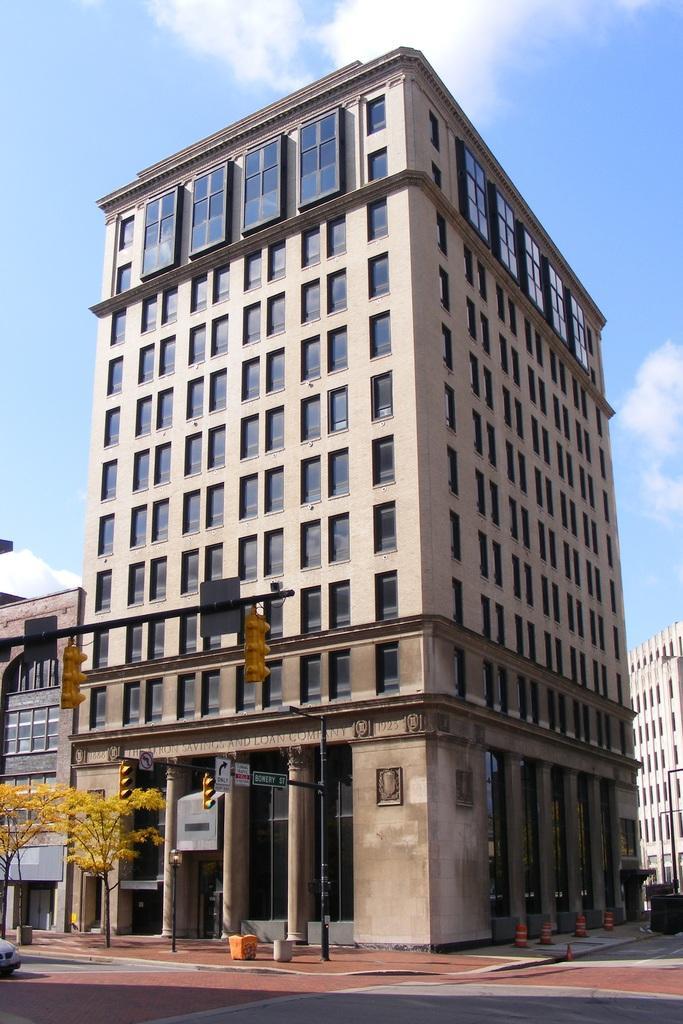How would you summarize this image in a sentence or two? In this image, we can see a building, there are some windows on the building, at the top there is a blue color sky. 